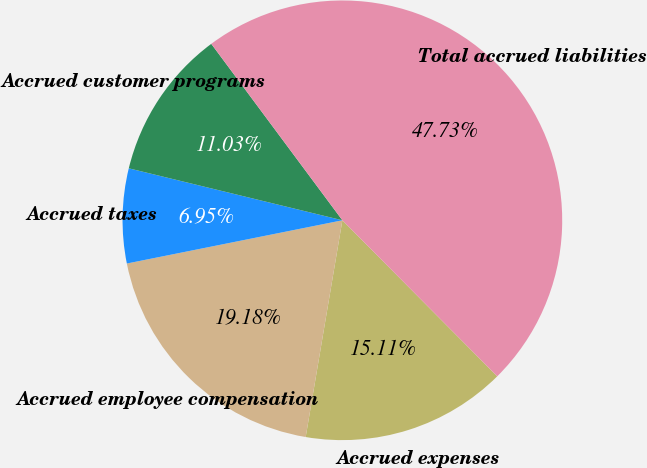Convert chart. <chart><loc_0><loc_0><loc_500><loc_500><pie_chart><fcel>Accrued expenses<fcel>Accrued employee compensation<fcel>Accrued taxes<fcel>Accrued customer programs<fcel>Total accrued liabilities<nl><fcel>15.11%<fcel>19.18%<fcel>6.95%<fcel>11.03%<fcel>47.73%<nl></chart> 